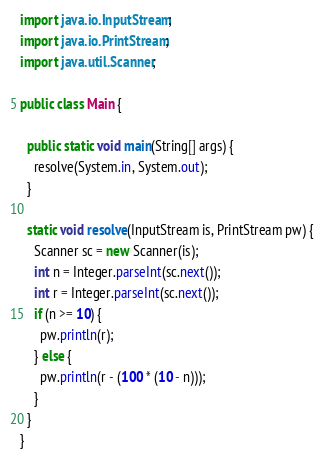<code> <loc_0><loc_0><loc_500><loc_500><_Java_>import java.io.InputStream;
import java.io.PrintStream;
import java.util.Scanner;

public class Main {

  public static void main(String[] args) {
    resolve(System.in, System.out);
  }

  static void resolve(InputStream is, PrintStream pw) {
    Scanner sc = new Scanner(is);
    int n = Integer.parseInt(sc.next());
    int r = Integer.parseInt(sc.next());
    if (n >= 10) {
      pw.println(r);
    } else {
      pw.println(r - (100 * (10 - n)));
    }
  }
}
</code> 